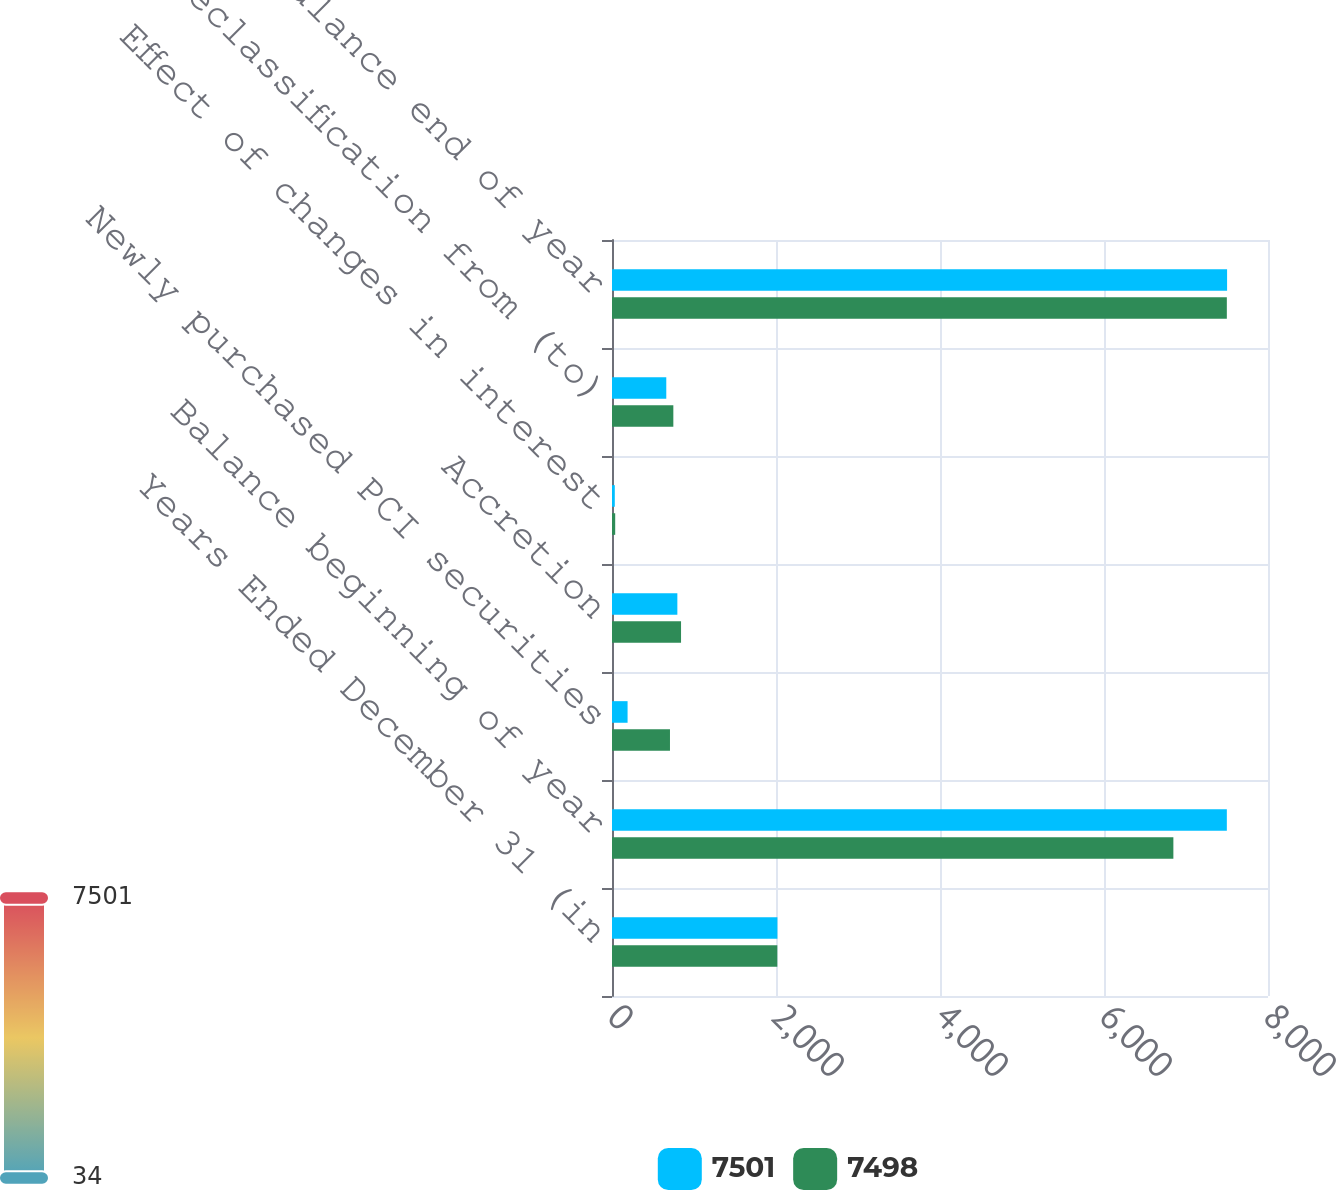Convert chart. <chart><loc_0><loc_0><loc_500><loc_500><stacked_bar_chart><ecel><fcel>Years Ended December 31 (in<fcel>Balance beginning of year<fcel>Newly purchased PCI securities<fcel>Accretion<fcel>Effect of changes in interest<fcel>Net reclassification from (to)<fcel>Balance end of year<nl><fcel>7501<fcel>2017<fcel>7498<fcel>190<fcel>797<fcel>34<fcel>662<fcel>7501<nl><fcel>7498<fcel>2016<fcel>6846<fcel>707<fcel>842<fcel>39<fcel>748<fcel>7498<nl></chart> 